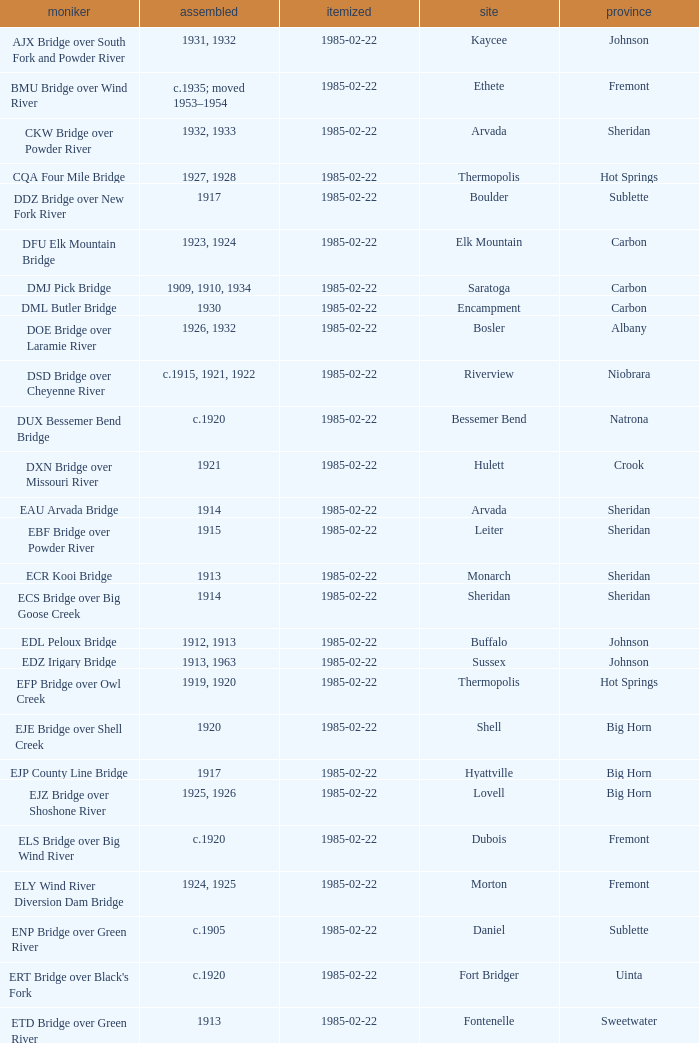What bridge in Sheridan county was built in 1915? EBF Bridge over Powder River. 